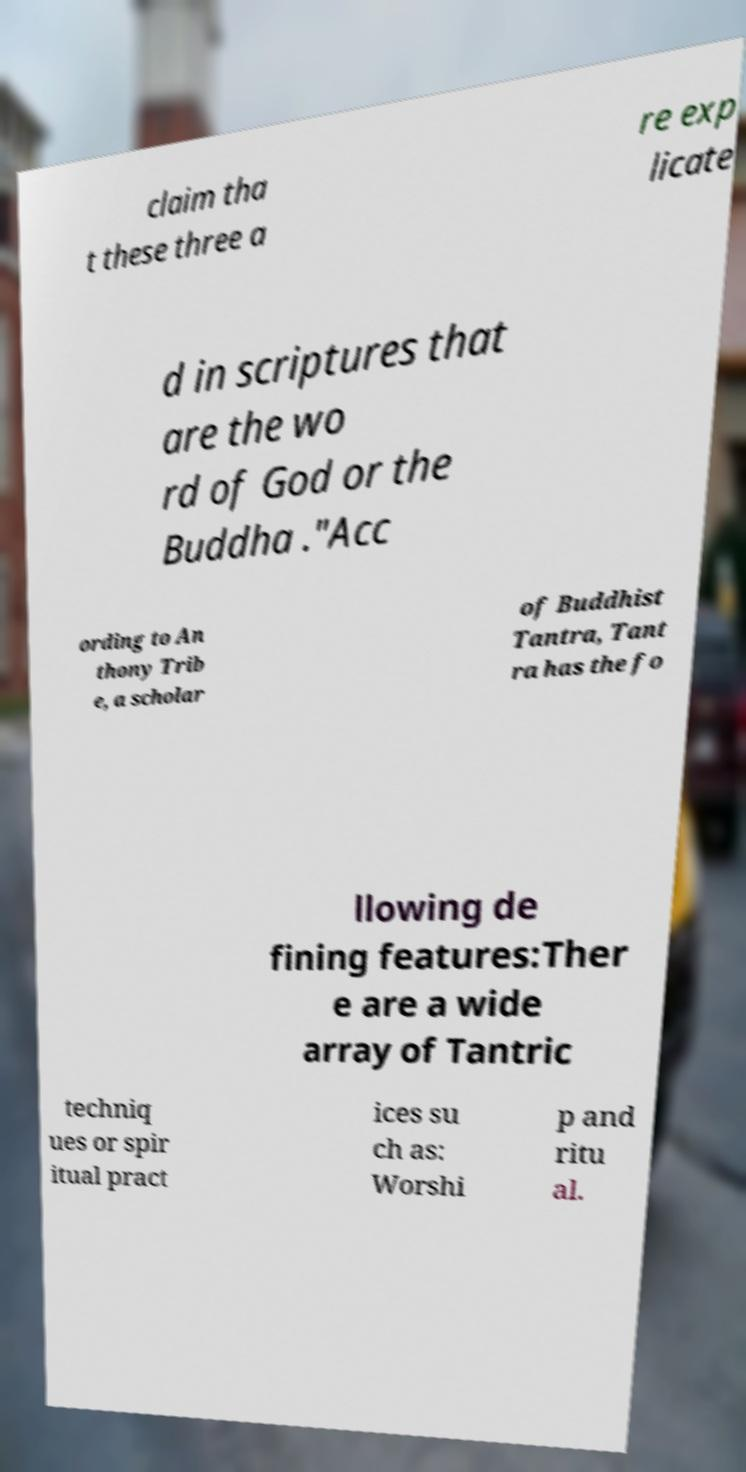Could you assist in decoding the text presented in this image and type it out clearly? claim tha t these three a re exp licate d in scriptures that are the wo rd of God or the Buddha ."Acc ording to An thony Trib e, a scholar of Buddhist Tantra, Tant ra has the fo llowing de fining features:Ther e are a wide array of Tantric techniq ues or spir itual pract ices su ch as: Worshi p and ritu al. 